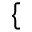Convert formula to latex. <formula><loc_0><loc_0><loc_500><loc_500>\{</formula> 